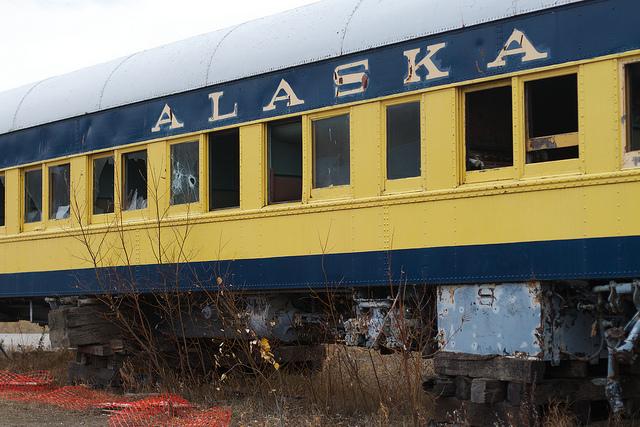What color is the area immediately around the windows?
Keep it brief. Yellow. What state is written on the train?
Write a very short answer. Alaska. Is this train in motion?
Give a very brief answer. No. 